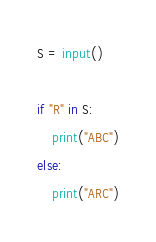Convert code to text. <code><loc_0><loc_0><loc_500><loc_500><_Python_>S = input()

if "R" in S:
    print("ABC")
else:
    print("ARC")
</code> 